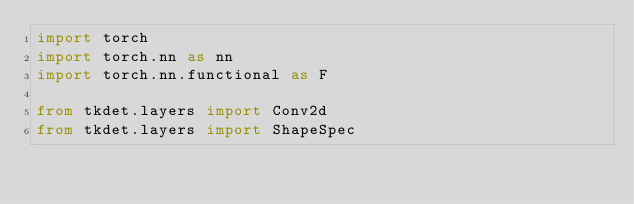Convert code to text. <code><loc_0><loc_0><loc_500><loc_500><_Python_>import torch
import torch.nn as nn
import torch.nn.functional as F

from tkdet.layers import Conv2d
from tkdet.layers import ShapeSpec</code> 